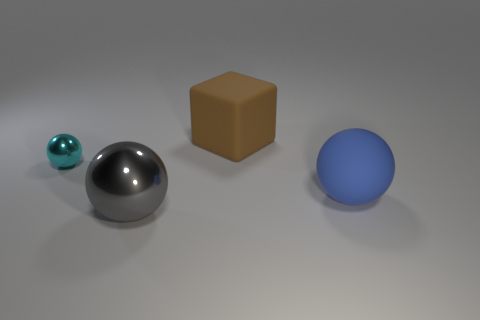Do the blue matte object and the big thing in front of the big blue sphere have the same shape?
Your answer should be compact. Yes. Is there a big block that has the same color as the small ball?
Make the answer very short. No. What is the material of the big brown cube?
Your response must be concise. Rubber. How many things are either matte cylinders or cyan balls?
Provide a short and direct response. 1. There is a metallic object that is behind the large matte sphere; what is its size?
Provide a succinct answer. Small. What number of other things are there of the same material as the large brown thing
Your answer should be very brief. 1. There is a matte thing that is behind the cyan shiny ball; are there any cyan shiny objects that are right of it?
Your answer should be compact. No. Are there any other things that have the same shape as the big brown rubber thing?
Your response must be concise. No. What color is the other shiny thing that is the same shape as the large gray metallic object?
Give a very brief answer. Cyan. How big is the brown object?
Your response must be concise. Large. 